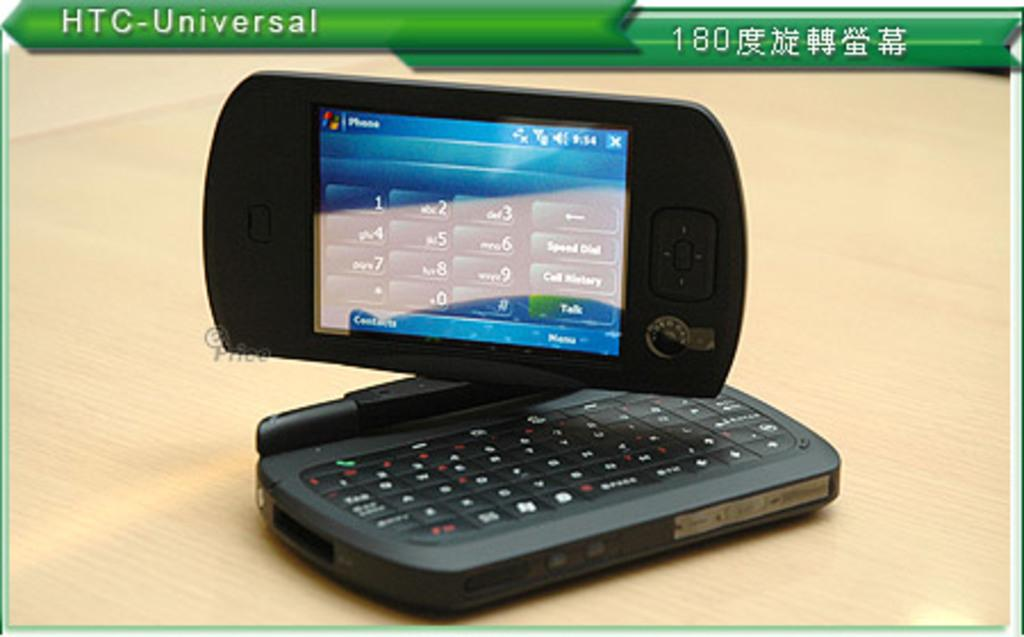<image>
Share a concise interpretation of the image provided. A photo of a phone is labelled as an HTC-Universal. 